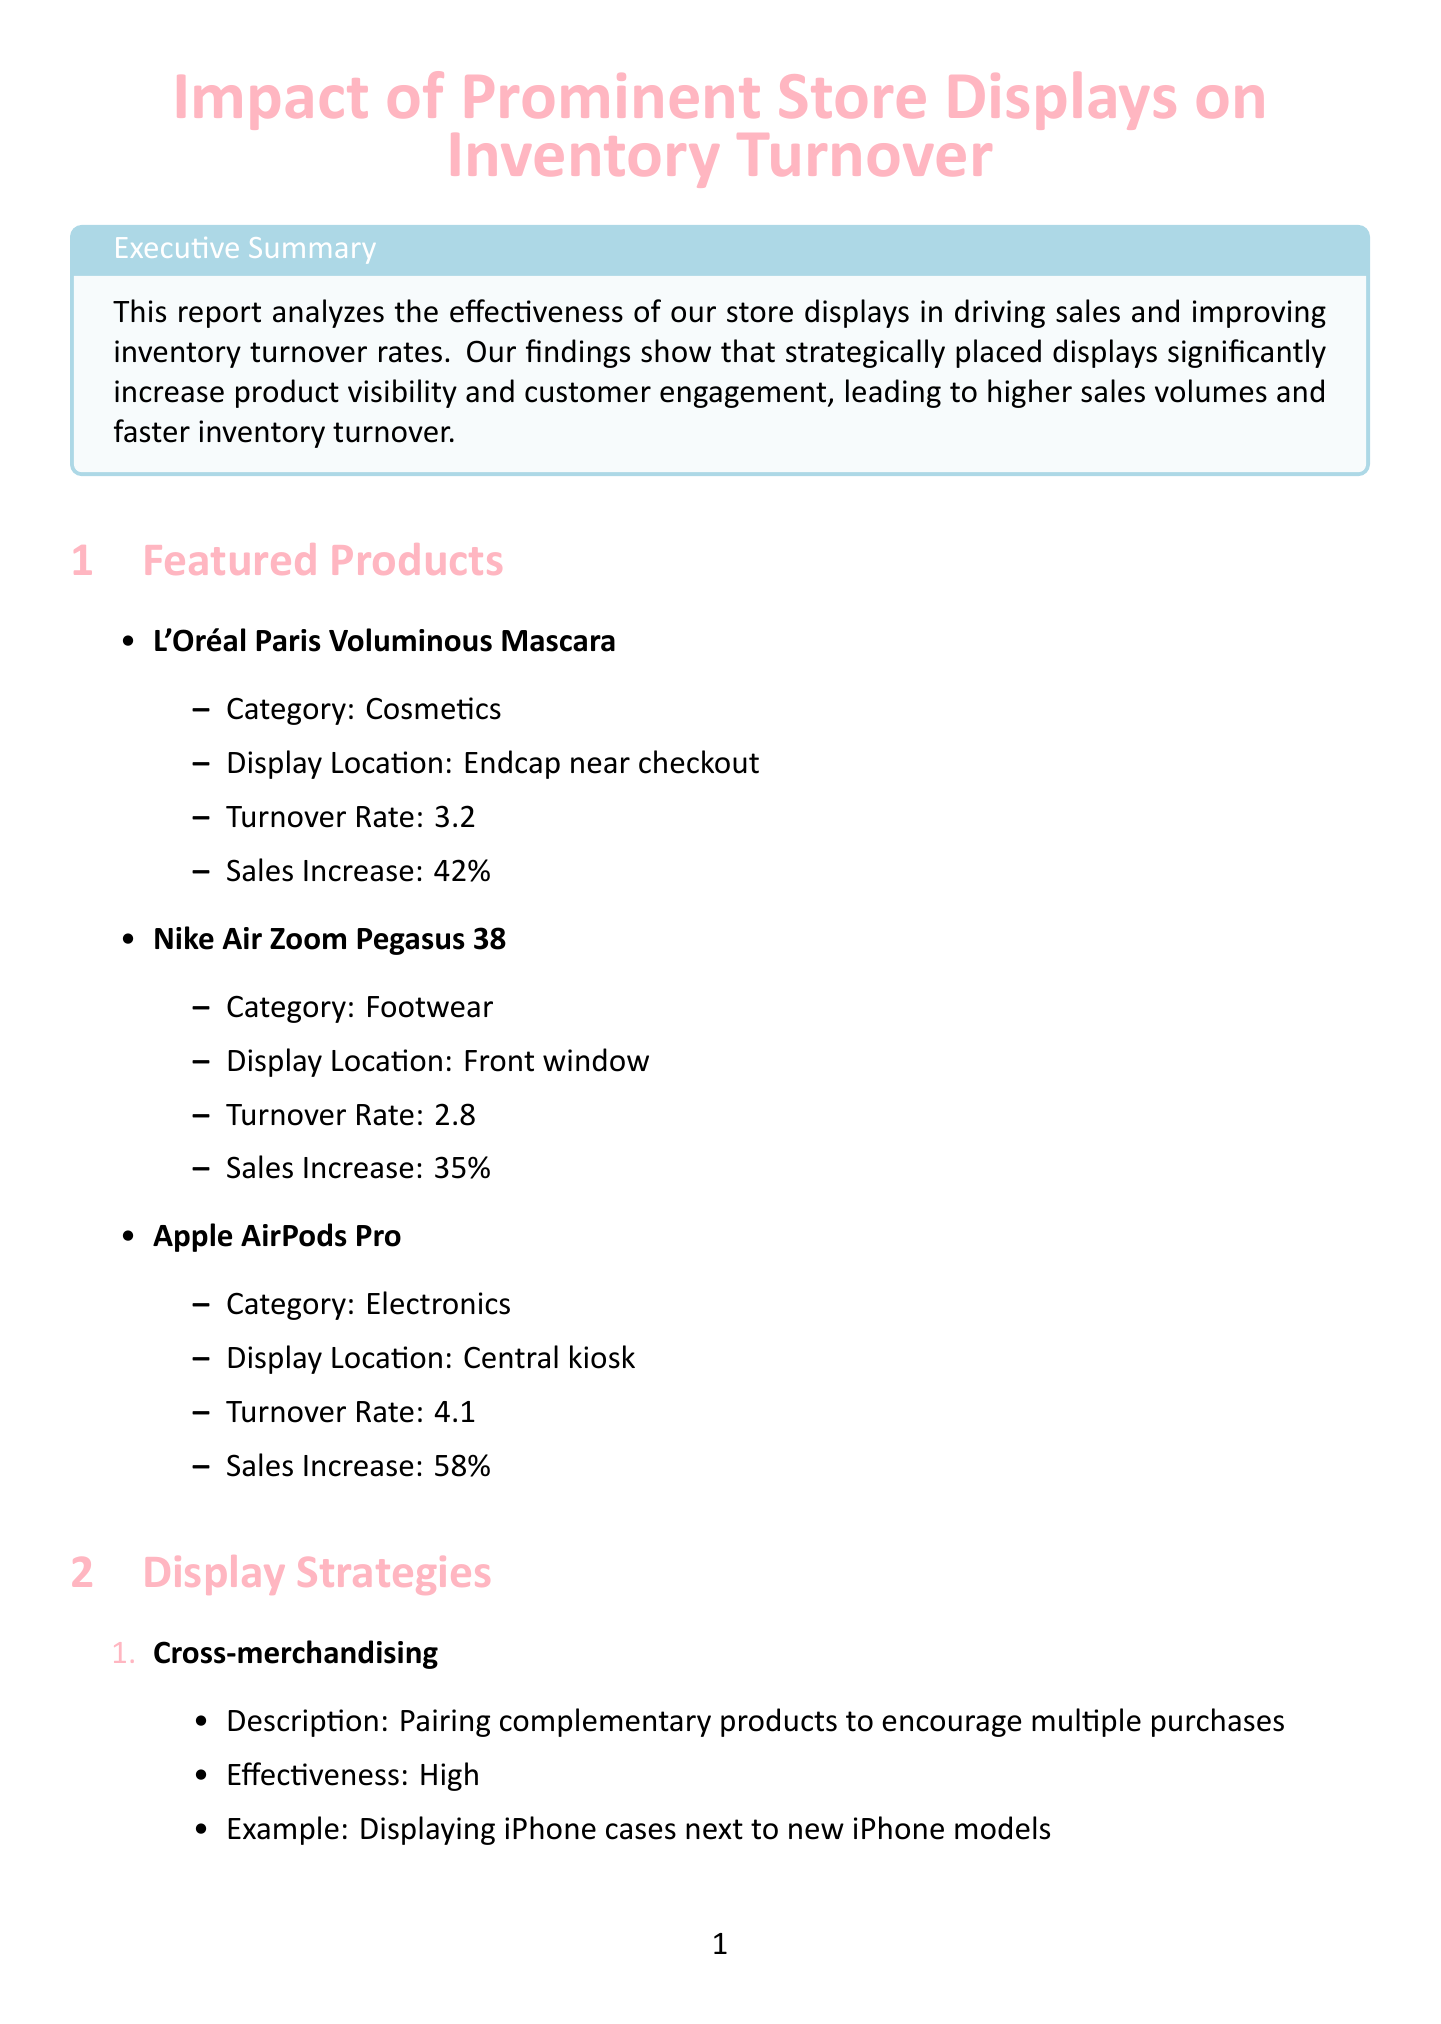What is the turnover rate for L'Oréal Paris Voluminous Mascara? The turnover rate for L'Oréal Paris Voluminous Mascara is stated in the document.
Answer: 3.2 Where was the Nike Air Zoom Pegasus 38 displayed? The document specifies the display location for the Nike Air Zoom Pegasus 38.
Answer: Front window What was the sales increase percentage of Apple AirPods Pro? The sales increase percentage for Apple AirPods Pro is highlighted in the report.
Answer: 58% Which display strategy has a "Very High" effectiveness rating? The document lists display strategies along with their effectiveness, indicating one as "Very High."
Answer: Interactive demonstrations What is the average time spent at displays by customers? The document provides information on customer behavior, including the average time spent at displays.
Answer: 3.5 minutes How much did Emily Thompson increase skincare product turnover by? The document shares achievements of sales associates, including Emily Thompson's impact.
Answer: 65% What type of displays are most effective according to customer behavior analysis? The document outlines the most effective display types based on customer analysis.
Answer: Interactive touchscreens What is one inventory management recommendation mentioned in the report? The document lists recommendations for inventory management practices.
Answer: Implement real-time tracking of display-featured items Which associate boosted electronics accessories sales by 50%? The report contains success stories highlighting specific associates and their achievements.
Answer: Michael Chen 